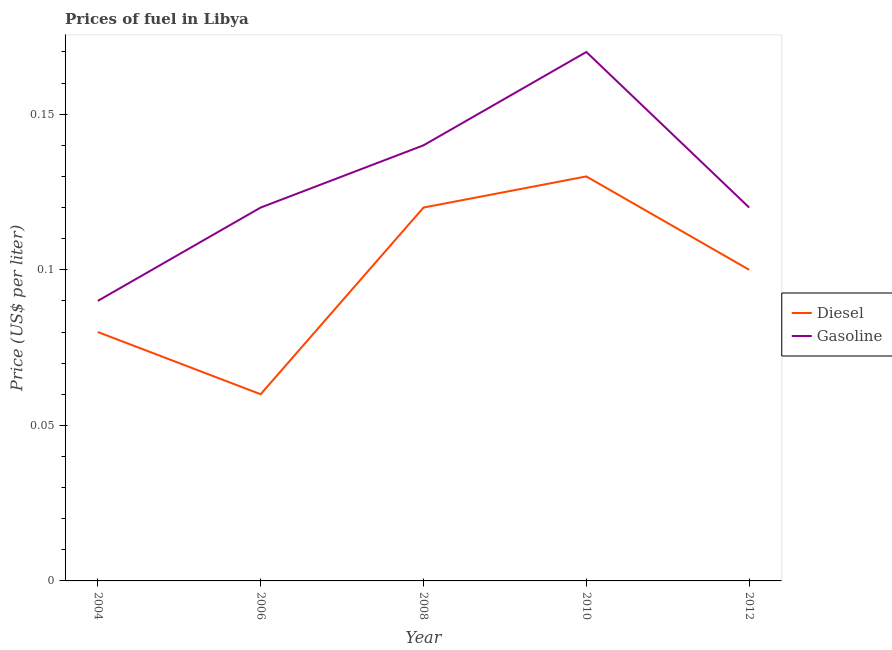How many different coloured lines are there?
Give a very brief answer. 2. Does the line corresponding to diesel price intersect with the line corresponding to gasoline price?
Offer a very short reply. No. Is the number of lines equal to the number of legend labels?
Keep it short and to the point. Yes. What is the gasoline price in 2012?
Make the answer very short. 0.12. Across all years, what is the maximum gasoline price?
Offer a very short reply. 0.17. Across all years, what is the minimum diesel price?
Ensure brevity in your answer.  0.06. What is the total diesel price in the graph?
Give a very brief answer. 0.49. What is the difference between the gasoline price in 2008 and that in 2012?
Your response must be concise. 0.02. What is the difference between the diesel price in 2006 and the gasoline price in 2008?
Keep it short and to the point. -0.08. What is the average gasoline price per year?
Your response must be concise. 0.13. In the year 2006, what is the difference between the diesel price and gasoline price?
Your response must be concise. -0.06. What is the ratio of the diesel price in 2004 to that in 2006?
Offer a very short reply. 1.33. Is the difference between the diesel price in 2004 and 2010 greater than the difference between the gasoline price in 2004 and 2010?
Make the answer very short. Yes. What is the difference between the highest and the second highest diesel price?
Offer a terse response. 0.01. What is the difference between the highest and the lowest gasoline price?
Provide a succinct answer. 0.08. Is the diesel price strictly greater than the gasoline price over the years?
Keep it short and to the point. No. Is the gasoline price strictly less than the diesel price over the years?
Keep it short and to the point. No. How many years are there in the graph?
Your answer should be very brief. 5. Are the values on the major ticks of Y-axis written in scientific E-notation?
Provide a succinct answer. No. Does the graph contain any zero values?
Your answer should be compact. No. Does the graph contain grids?
Make the answer very short. No. Where does the legend appear in the graph?
Ensure brevity in your answer.  Center right. How are the legend labels stacked?
Your answer should be very brief. Vertical. What is the title of the graph?
Your response must be concise. Prices of fuel in Libya. What is the label or title of the Y-axis?
Offer a terse response. Price (US$ per liter). What is the Price (US$ per liter) of Gasoline in 2004?
Offer a terse response. 0.09. What is the Price (US$ per liter) in Diesel in 2006?
Provide a succinct answer. 0.06. What is the Price (US$ per liter) of Gasoline in 2006?
Your answer should be compact. 0.12. What is the Price (US$ per liter) of Diesel in 2008?
Your answer should be very brief. 0.12. What is the Price (US$ per liter) in Gasoline in 2008?
Make the answer very short. 0.14. What is the Price (US$ per liter) in Diesel in 2010?
Ensure brevity in your answer.  0.13. What is the Price (US$ per liter) in Gasoline in 2010?
Your answer should be compact. 0.17. What is the Price (US$ per liter) in Gasoline in 2012?
Ensure brevity in your answer.  0.12. Across all years, what is the maximum Price (US$ per liter) of Diesel?
Make the answer very short. 0.13. Across all years, what is the maximum Price (US$ per liter) of Gasoline?
Your response must be concise. 0.17. Across all years, what is the minimum Price (US$ per liter) in Diesel?
Your answer should be compact. 0.06. Across all years, what is the minimum Price (US$ per liter) in Gasoline?
Provide a succinct answer. 0.09. What is the total Price (US$ per liter) of Diesel in the graph?
Make the answer very short. 0.49. What is the total Price (US$ per liter) of Gasoline in the graph?
Your response must be concise. 0.64. What is the difference between the Price (US$ per liter) in Diesel in 2004 and that in 2006?
Ensure brevity in your answer.  0.02. What is the difference between the Price (US$ per liter) of Gasoline in 2004 and that in 2006?
Provide a short and direct response. -0.03. What is the difference between the Price (US$ per liter) in Diesel in 2004 and that in 2008?
Provide a short and direct response. -0.04. What is the difference between the Price (US$ per liter) in Diesel in 2004 and that in 2010?
Keep it short and to the point. -0.05. What is the difference between the Price (US$ per liter) of Gasoline in 2004 and that in 2010?
Offer a terse response. -0.08. What is the difference between the Price (US$ per liter) of Diesel in 2004 and that in 2012?
Give a very brief answer. -0.02. What is the difference between the Price (US$ per liter) in Gasoline in 2004 and that in 2012?
Provide a succinct answer. -0.03. What is the difference between the Price (US$ per liter) of Diesel in 2006 and that in 2008?
Offer a very short reply. -0.06. What is the difference between the Price (US$ per liter) of Gasoline in 2006 and that in 2008?
Offer a very short reply. -0.02. What is the difference between the Price (US$ per liter) of Diesel in 2006 and that in 2010?
Offer a very short reply. -0.07. What is the difference between the Price (US$ per liter) in Diesel in 2006 and that in 2012?
Offer a terse response. -0.04. What is the difference between the Price (US$ per liter) of Diesel in 2008 and that in 2010?
Provide a short and direct response. -0.01. What is the difference between the Price (US$ per liter) in Gasoline in 2008 and that in 2010?
Your answer should be very brief. -0.03. What is the difference between the Price (US$ per liter) in Diesel in 2008 and that in 2012?
Your response must be concise. 0.02. What is the difference between the Price (US$ per liter) of Gasoline in 2008 and that in 2012?
Your response must be concise. 0.02. What is the difference between the Price (US$ per liter) in Diesel in 2010 and that in 2012?
Keep it short and to the point. 0.03. What is the difference between the Price (US$ per liter) in Diesel in 2004 and the Price (US$ per liter) in Gasoline in 2006?
Your answer should be very brief. -0.04. What is the difference between the Price (US$ per liter) in Diesel in 2004 and the Price (US$ per liter) in Gasoline in 2008?
Provide a short and direct response. -0.06. What is the difference between the Price (US$ per liter) in Diesel in 2004 and the Price (US$ per liter) in Gasoline in 2010?
Your answer should be compact. -0.09. What is the difference between the Price (US$ per liter) of Diesel in 2004 and the Price (US$ per liter) of Gasoline in 2012?
Offer a very short reply. -0.04. What is the difference between the Price (US$ per liter) of Diesel in 2006 and the Price (US$ per liter) of Gasoline in 2008?
Keep it short and to the point. -0.08. What is the difference between the Price (US$ per liter) in Diesel in 2006 and the Price (US$ per liter) in Gasoline in 2010?
Your answer should be very brief. -0.11. What is the difference between the Price (US$ per liter) of Diesel in 2006 and the Price (US$ per liter) of Gasoline in 2012?
Give a very brief answer. -0.06. What is the difference between the Price (US$ per liter) in Diesel in 2010 and the Price (US$ per liter) in Gasoline in 2012?
Provide a succinct answer. 0.01. What is the average Price (US$ per liter) in Diesel per year?
Your response must be concise. 0.1. What is the average Price (US$ per liter) of Gasoline per year?
Your answer should be compact. 0.13. In the year 2004, what is the difference between the Price (US$ per liter) of Diesel and Price (US$ per liter) of Gasoline?
Your answer should be compact. -0.01. In the year 2006, what is the difference between the Price (US$ per liter) in Diesel and Price (US$ per liter) in Gasoline?
Make the answer very short. -0.06. In the year 2008, what is the difference between the Price (US$ per liter) in Diesel and Price (US$ per liter) in Gasoline?
Your response must be concise. -0.02. In the year 2010, what is the difference between the Price (US$ per liter) of Diesel and Price (US$ per liter) of Gasoline?
Your answer should be very brief. -0.04. In the year 2012, what is the difference between the Price (US$ per liter) in Diesel and Price (US$ per liter) in Gasoline?
Your answer should be very brief. -0.02. What is the ratio of the Price (US$ per liter) of Diesel in 2004 to that in 2006?
Provide a succinct answer. 1.33. What is the ratio of the Price (US$ per liter) in Gasoline in 2004 to that in 2006?
Your answer should be compact. 0.75. What is the ratio of the Price (US$ per liter) in Diesel in 2004 to that in 2008?
Your answer should be compact. 0.67. What is the ratio of the Price (US$ per liter) in Gasoline in 2004 to that in 2008?
Provide a succinct answer. 0.64. What is the ratio of the Price (US$ per liter) of Diesel in 2004 to that in 2010?
Provide a succinct answer. 0.62. What is the ratio of the Price (US$ per liter) in Gasoline in 2004 to that in 2010?
Keep it short and to the point. 0.53. What is the ratio of the Price (US$ per liter) in Diesel in 2006 to that in 2010?
Your answer should be very brief. 0.46. What is the ratio of the Price (US$ per liter) of Gasoline in 2006 to that in 2010?
Offer a very short reply. 0.71. What is the ratio of the Price (US$ per liter) in Diesel in 2006 to that in 2012?
Give a very brief answer. 0.6. What is the ratio of the Price (US$ per liter) in Gasoline in 2008 to that in 2010?
Your answer should be very brief. 0.82. What is the ratio of the Price (US$ per liter) of Diesel in 2008 to that in 2012?
Ensure brevity in your answer.  1.2. What is the ratio of the Price (US$ per liter) of Diesel in 2010 to that in 2012?
Provide a short and direct response. 1.3. What is the ratio of the Price (US$ per liter) in Gasoline in 2010 to that in 2012?
Your answer should be compact. 1.42. What is the difference between the highest and the second highest Price (US$ per liter) of Gasoline?
Your answer should be compact. 0.03. What is the difference between the highest and the lowest Price (US$ per liter) of Diesel?
Give a very brief answer. 0.07. What is the difference between the highest and the lowest Price (US$ per liter) of Gasoline?
Keep it short and to the point. 0.08. 